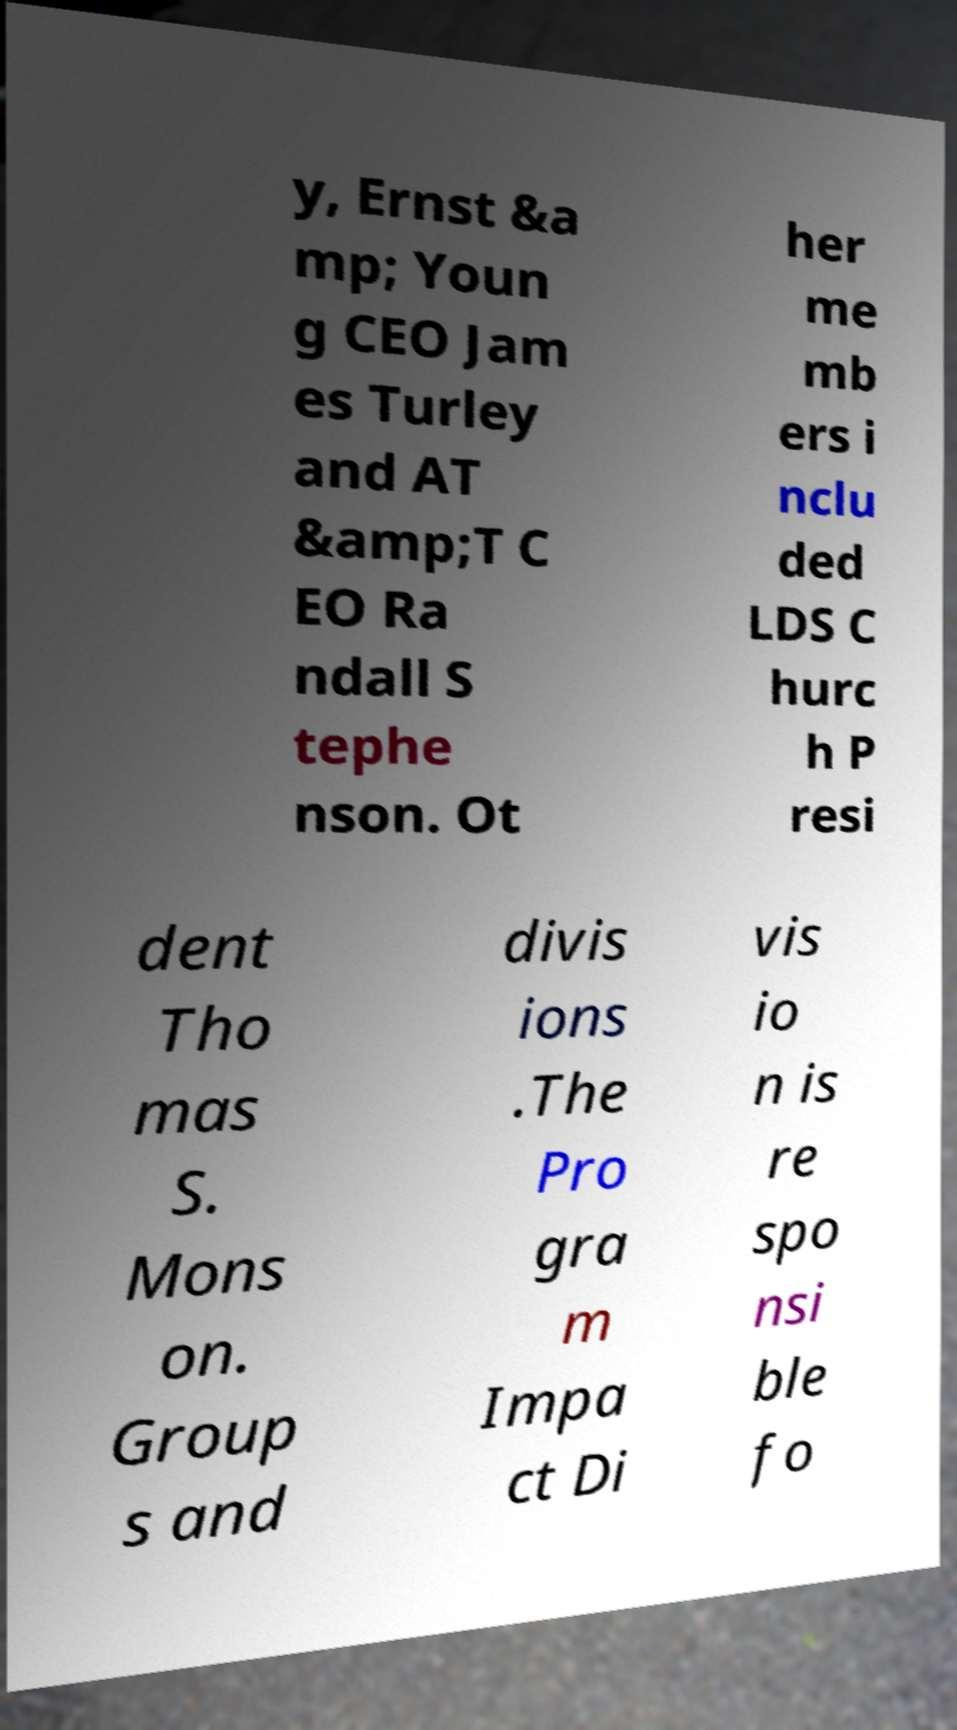What messages or text are displayed in this image? I need them in a readable, typed format. y, Ernst &a mp; Youn g CEO Jam es Turley and AT &amp;T C EO Ra ndall S tephe nson. Ot her me mb ers i nclu ded LDS C hurc h P resi dent Tho mas S. Mons on. Group s and divis ions .The Pro gra m Impa ct Di vis io n is re spo nsi ble fo 